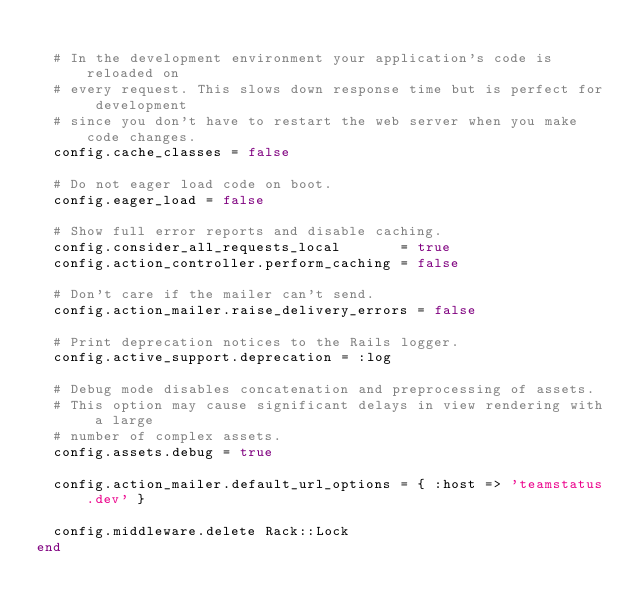<code> <loc_0><loc_0><loc_500><loc_500><_Ruby_>
  # In the development environment your application's code is reloaded on
  # every request. This slows down response time but is perfect for development
  # since you don't have to restart the web server when you make code changes.
  config.cache_classes = false

  # Do not eager load code on boot.
  config.eager_load = false

  # Show full error reports and disable caching.
  config.consider_all_requests_local       = true
  config.action_controller.perform_caching = false

  # Don't care if the mailer can't send.
  config.action_mailer.raise_delivery_errors = false

  # Print deprecation notices to the Rails logger.
  config.active_support.deprecation = :log

  # Debug mode disables concatenation and preprocessing of assets.
  # This option may cause significant delays in view rendering with a large
  # number of complex assets.
  config.assets.debug = true

  config.action_mailer.default_url_options = { :host => 'teamstatus.dev' }

  config.middleware.delete Rack::Lock
end
</code> 